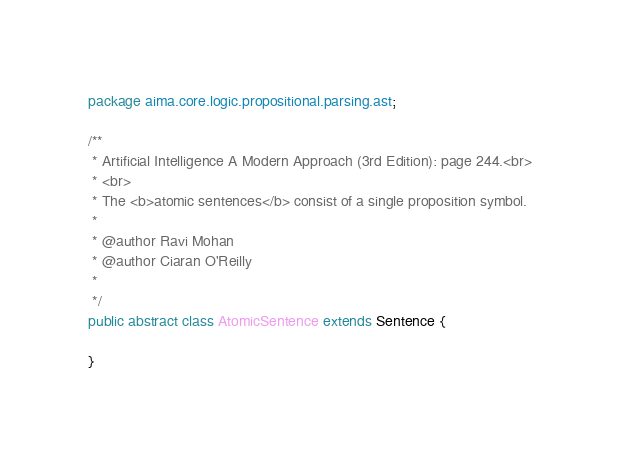<code> <loc_0><loc_0><loc_500><loc_500><_Java_>package aima.core.logic.propositional.parsing.ast;

/**
 * Artificial Intelligence A Modern Approach (3rd Edition): page 244.<br>
 * <br>
 * The <b>atomic sentences</b> consist of a single proposition symbol.
 * 
 * @author Ravi Mohan
 * @author Ciaran O'Reilly
 * 
 */
public abstract class AtomicSentence extends Sentence {

}</code> 